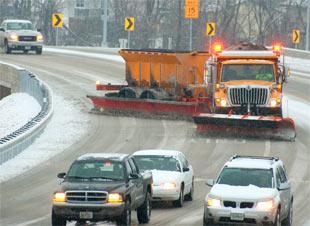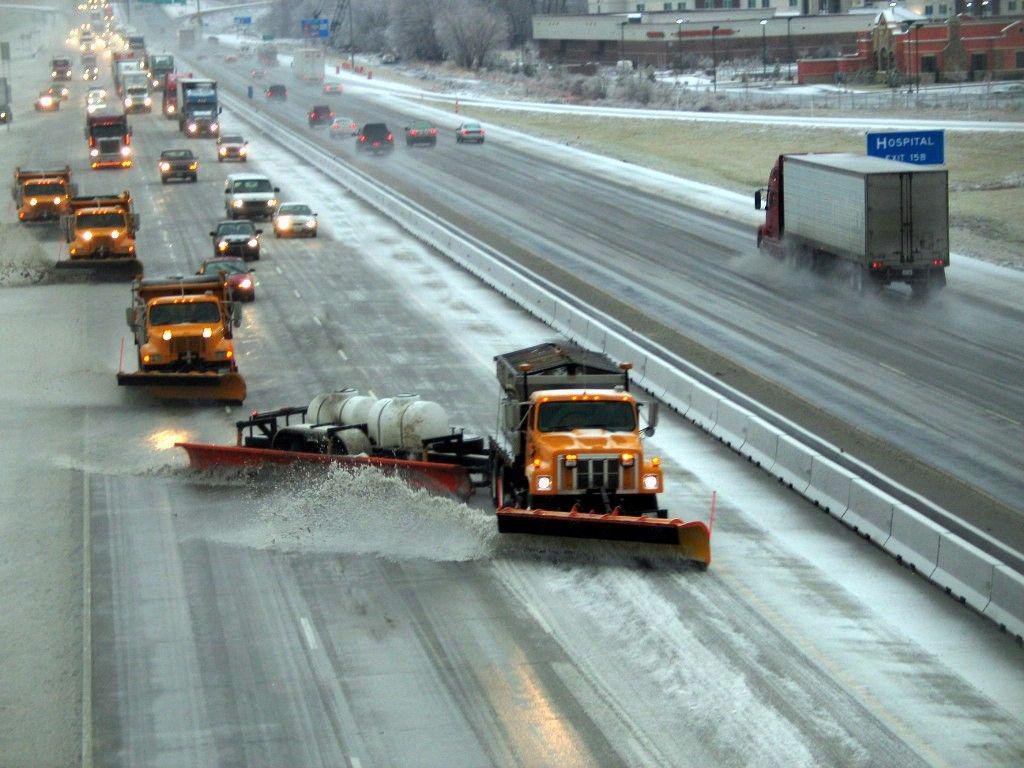The first image is the image on the left, the second image is the image on the right. Evaluate the accuracy of this statement regarding the images: "Both images show at least one camera-facing tow plow truck with a yellow cab, clearing a snowy road.". Is it true? Answer yes or no. Yes. 